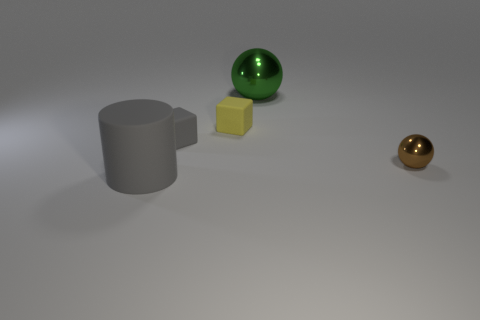Subtract all purple cubes. Subtract all blue cylinders. How many cubes are left? 2 Add 2 yellow matte blocks. How many objects exist? 7 Subtract all balls. How many objects are left? 3 Subtract all blocks. Subtract all metal things. How many objects are left? 1 Add 4 small gray matte things. How many small gray matte things are left? 5 Add 5 big metal objects. How many big metal objects exist? 6 Subtract 1 brown spheres. How many objects are left? 4 